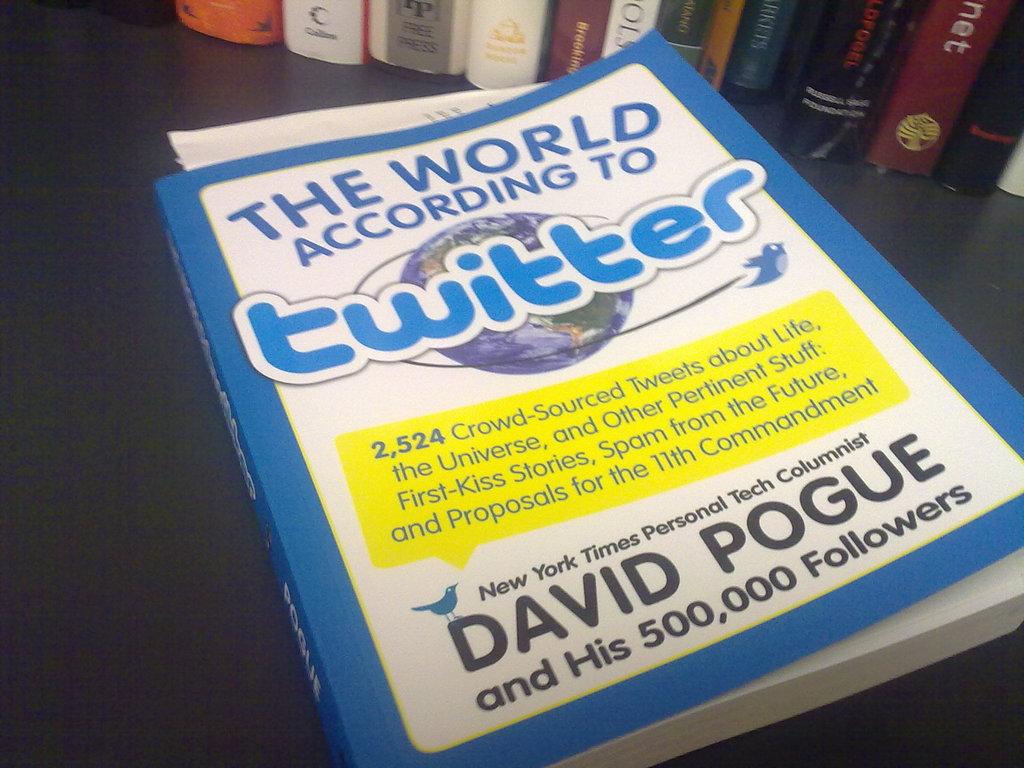Who wrote this book?
Provide a succinct answer. David pogue. What social media platform is this book about?
Keep it short and to the point. Twitter. 